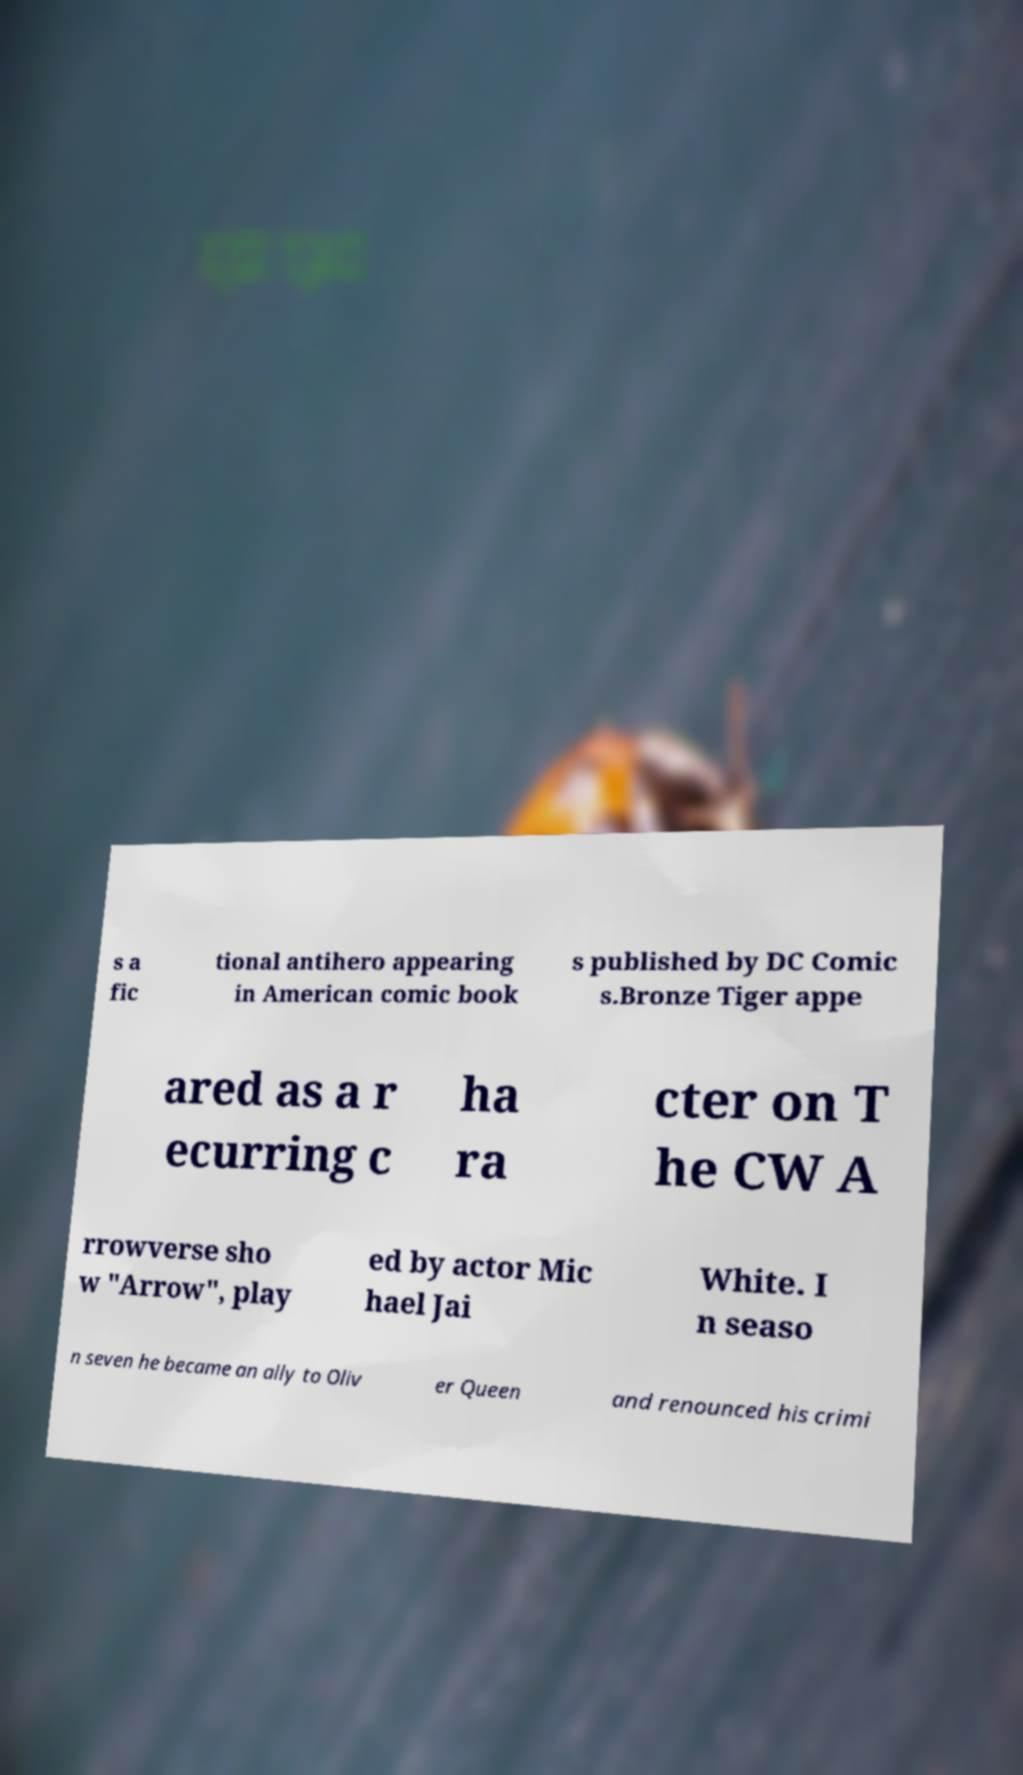Please read and relay the text visible in this image. What does it say? s a fic tional antihero appearing in American comic book s published by DC Comic s.Bronze Tiger appe ared as a r ecurring c ha ra cter on T he CW A rrowverse sho w "Arrow", play ed by actor Mic hael Jai White. I n seaso n seven he became an ally to Oliv er Queen and renounced his crimi 